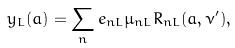Convert formula to latex. <formula><loc_0><loc_0><loc_500><loc_500>y _ { L } ( a ) = \sum _ { n } e _ { n L } \mu _ { n L } R _ { n L } ( a , \nu ^ { \prime } ) ,</formula> 